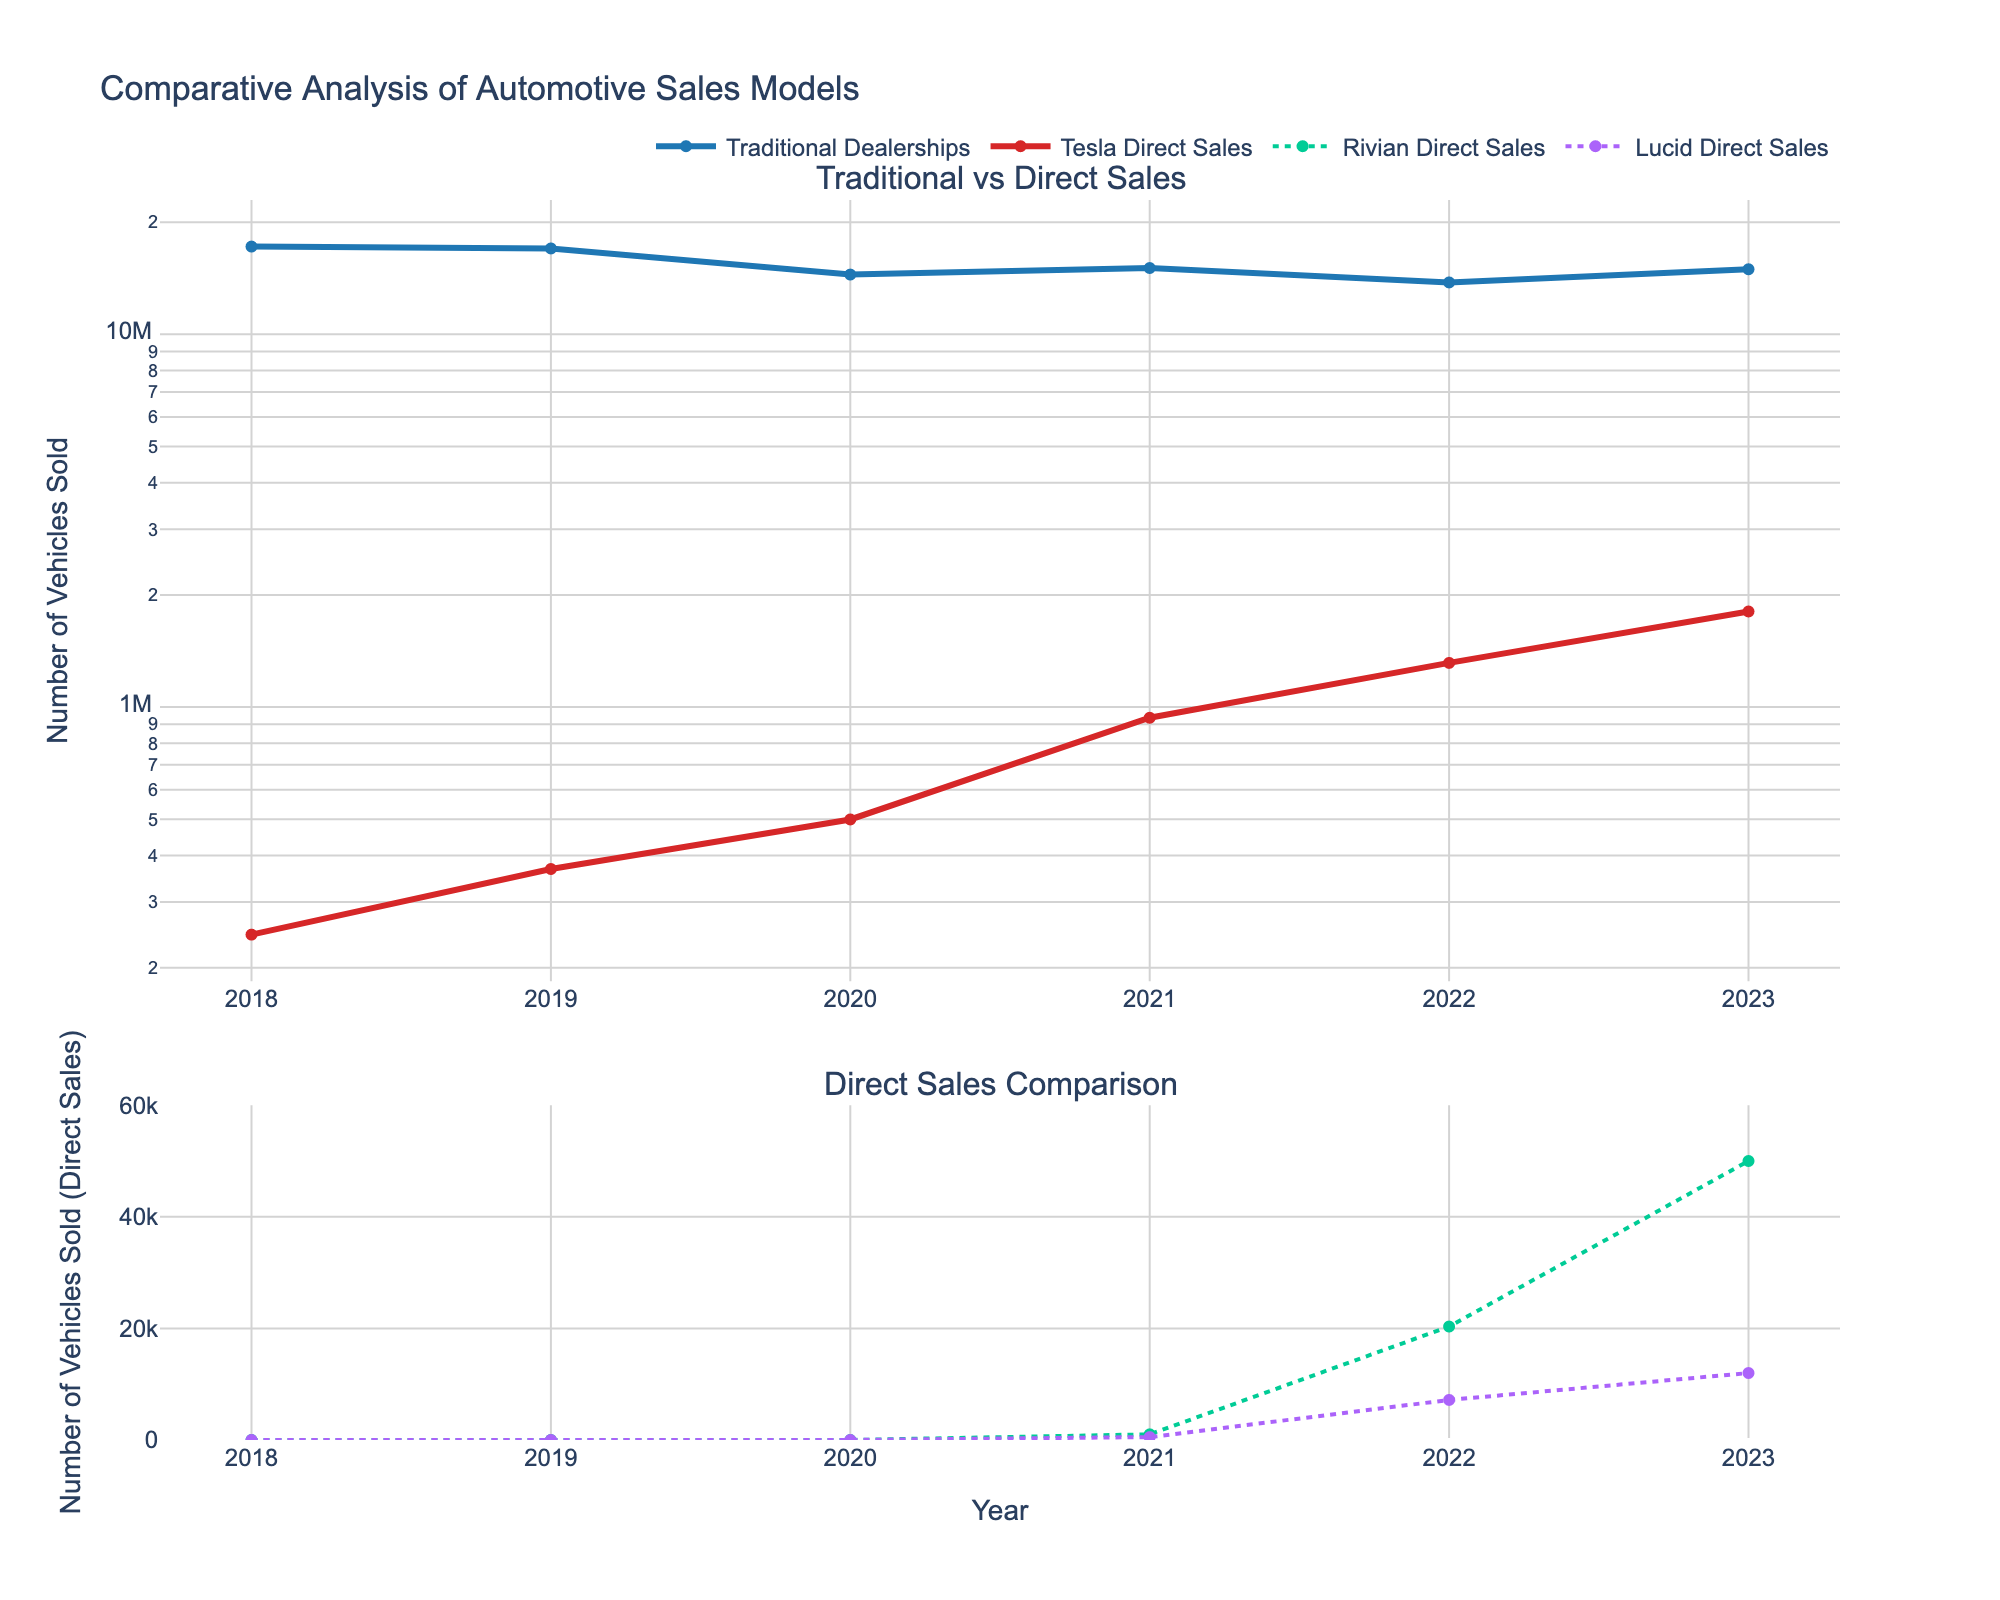What is the title of the figure? The title can be found at the top of the plot. It usually describes the overall subject of the figure.
Answer: Energy Efficiency of Household Appliances (1970-2020) How do the energy consumption trends of refrigerators and washing machines look between 1970 and 2020? Look at the line chart on the top left subplot. Both appliances show a downward trend in energy consumption over the years, indicating improvement in energy efficiency.
Answer: Both are decreasing Which appliance shows the greatest reduction in energy consumption from 1970 to 2020? Examine the endpoints (1970 and 2020) for each appliance. The refrigerator starts at 1800 kWh/year in 1970 and ends at 350 kWh/year in 2020, a reduction of 1450 kWh/year. Other appliances show smaller reductions.
Answer: Refrigerator What year does the dishwasher consume approximately 1100 kWh/year? Refer to the bar chart in the top right subplot. The tallest bar is for the year 1980, which shows energy consumption around 1100 kWh/year.
Answer: 1980 Between 1990 and 2010, which appliance shows a constant trend in its energy consumption? Check all subplots for trends between the given years. The vacuum cleaner in the bottom right subplot shows the most constant trend compared to other appliances.
Answer: Vacuum Cleaner How much energy does the Vacuum Cleaner consume in the year 2000? Look at the area chart in the bottom right subplot. The point for the year 2000 shows energy consumption around 450 kWh/year.
Answer: 450 kWh/year Compare the energy consumption of microwaves in 1990 to that in 2020. Refer to the scatter plot in the bottom left subplot for these points. In 1990, microwaves consume about 180 kWh/year and in 2020, they consume about 100 kWh/year.
Answer: Lower in 2020 What is the reduction in the energy consumption of washing machines from 1980 to 2010? Find the values for the washing machine in both years in the line chart. 340 kWh/year in 1980 and 220 kWh/year in 2010, so the reduction is 340 - 220 = 120 kWh/year.
Answer: 120 kWh/year Which appliance shows a star-shaped marker representing its data points? Look at the scatter plot and notice the marker shapes. The star-shaped markers are used for the microwave.
Answer: Microwave 